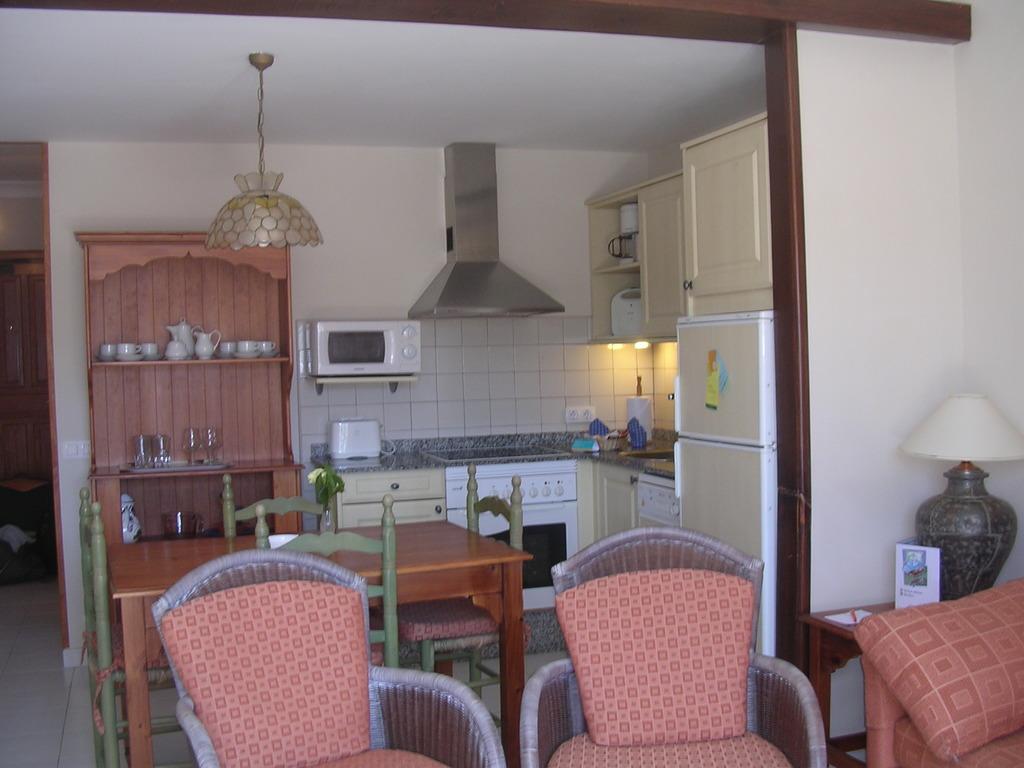Can you describe this image briefly? In this image we can see chairs, tables. In the background of the image there is a kitchen platform. There is an oven, chimney. There is a cupboard in which there are objects. At the top of the image there is a ceiling with light. To the left side of the image there is a door. 